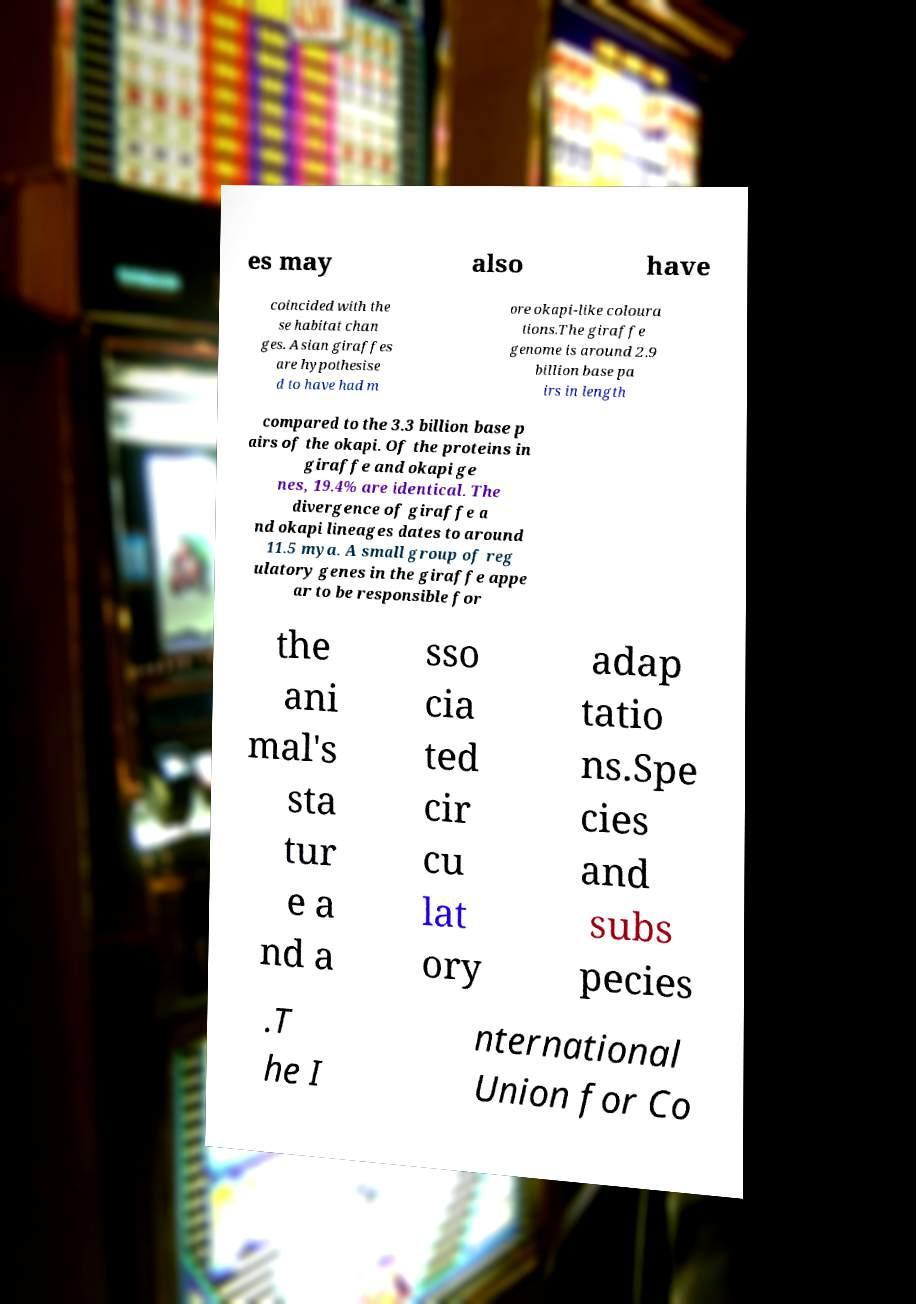What messages or text are displayed in this image? I need them in a readable, typed format. es may also have coincided with the se habitat chan ges. Asian giraffes are hypothesise d to have had m ore okapi-like coloura tions.The giraffe genome is around 2.9 billion base pa irs in length compared to the 3.3 billion base p airs of the okapi. Of the proteins in giraffe and okapi ge nes, 19.4% are identical. The divergence of giraffe a nd okapi lineages dates to around 11.5 mya. A small group of reg ulatory genes in the giraffe appe ar to be responsible for the ani mal's sta tur e a nd a sso cia ted cir cu lat ory adap tatio ns.Spe cies and subs pecies .T he I nternational Union for Co 